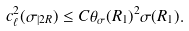Convert formula to latex. <formula><loc_0><loc_0><loc_500><loc_500>c ^ { 2 } _ { \ell } ( \sigma _ { | 2 R } ) \leq C \theta _ { \sigma } ( R _ { 1 } ) ^ { 2 } \sigma ( R _ { 1 } ) .</formula> 